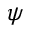Convert formula to latex. <formula><loc_0><loc_0><loc_500><loc_500>\psi</formula> 